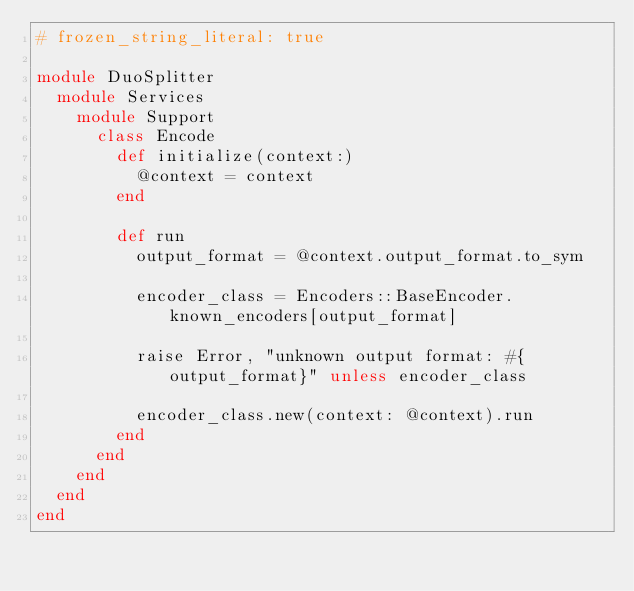Convert code to text. <code><loc_0><loc_0><loc_500><loc_500><_Ruby_># frozen_string_literal: true

module DuoSplitter
  module Services
    module Support
      class Encode
        def initialize(context:)
          @context = context
        end

        def run
          output_format = @context.output_format.to_sym

          encoder_class = Encoders::BaseEncoder.known_encoders[output_format]

          raise Error, "unknown output format: #{output_format}" unless encoder_class

          encoder_class.new(context: @context).run
        end
      end
    end
  end
end
</code> 